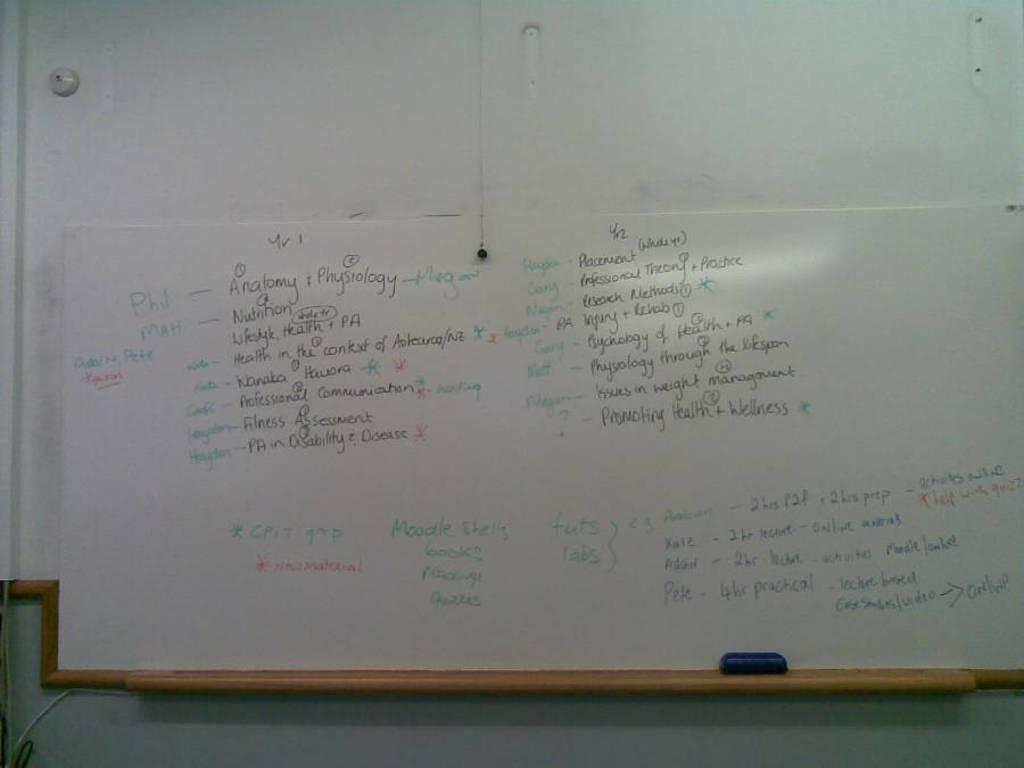<image>
Provide a brief description of the given image. A whiteboard with writing on it, the word Anatomy is visible. 